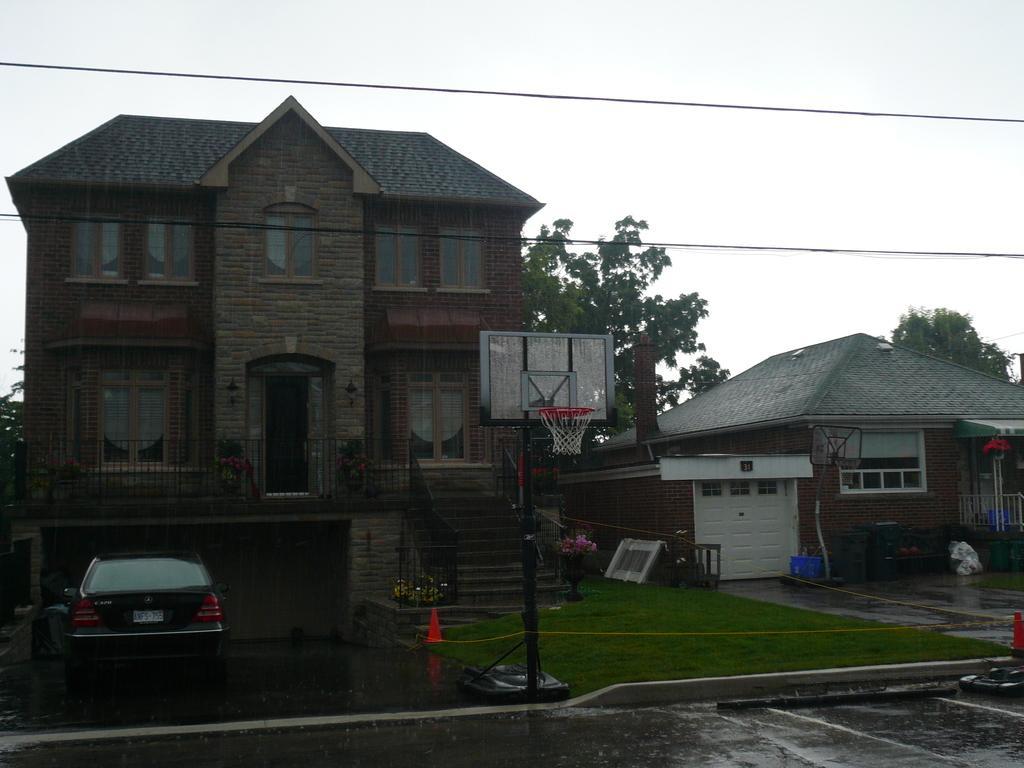Please provide a concise description of this image. In the center of the image we can see buildings, stairs, grills, door, windows, volleyball court, house, flower pot, car, trees, wires, grass, divider cone are there. At the top of the image sky is there. At the bottom of the image ground is there. 